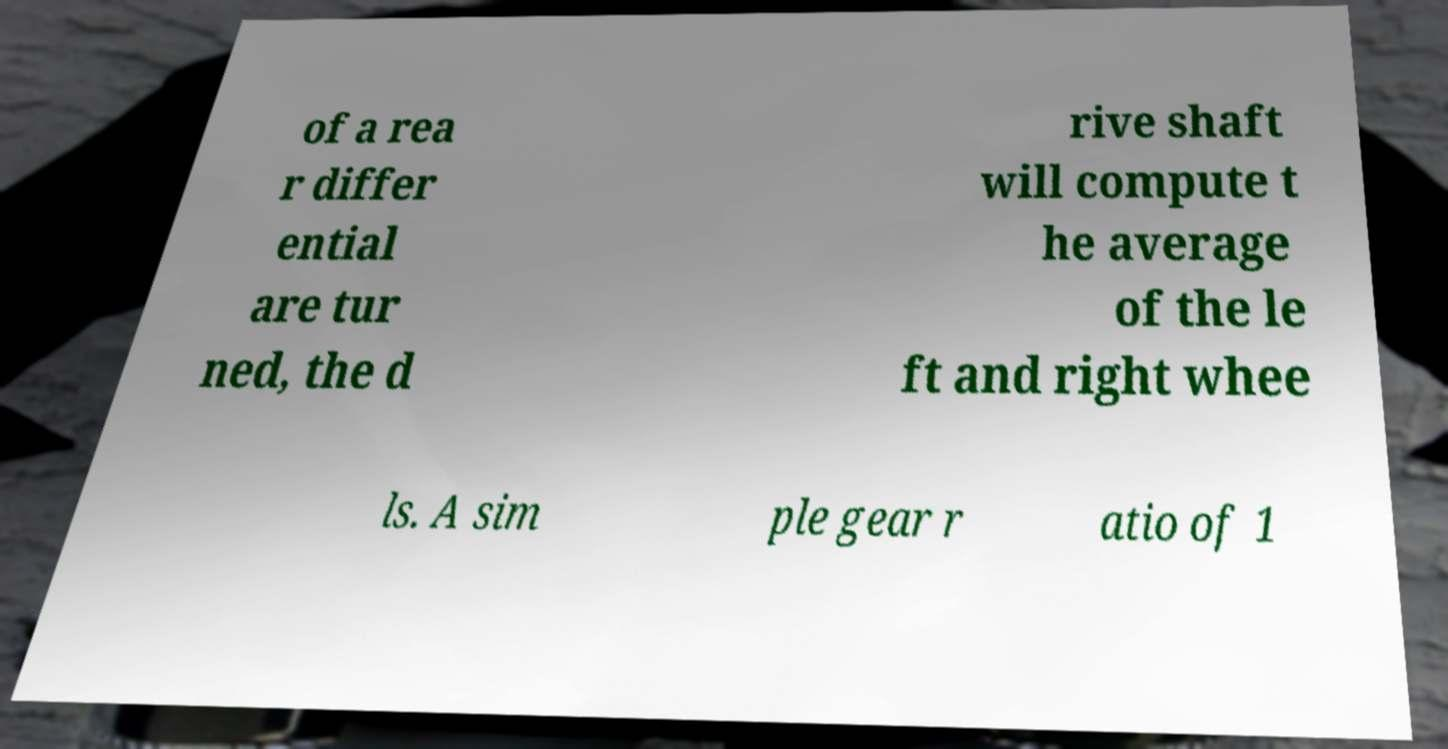There's text embedded in this image that I need extracted. Can you transcribe it verbatim? of a rea r differ ential are tur ned, the d rive shaft will compute t he average of the le ft and right whee ls. A sim ple gear r atio of 1 